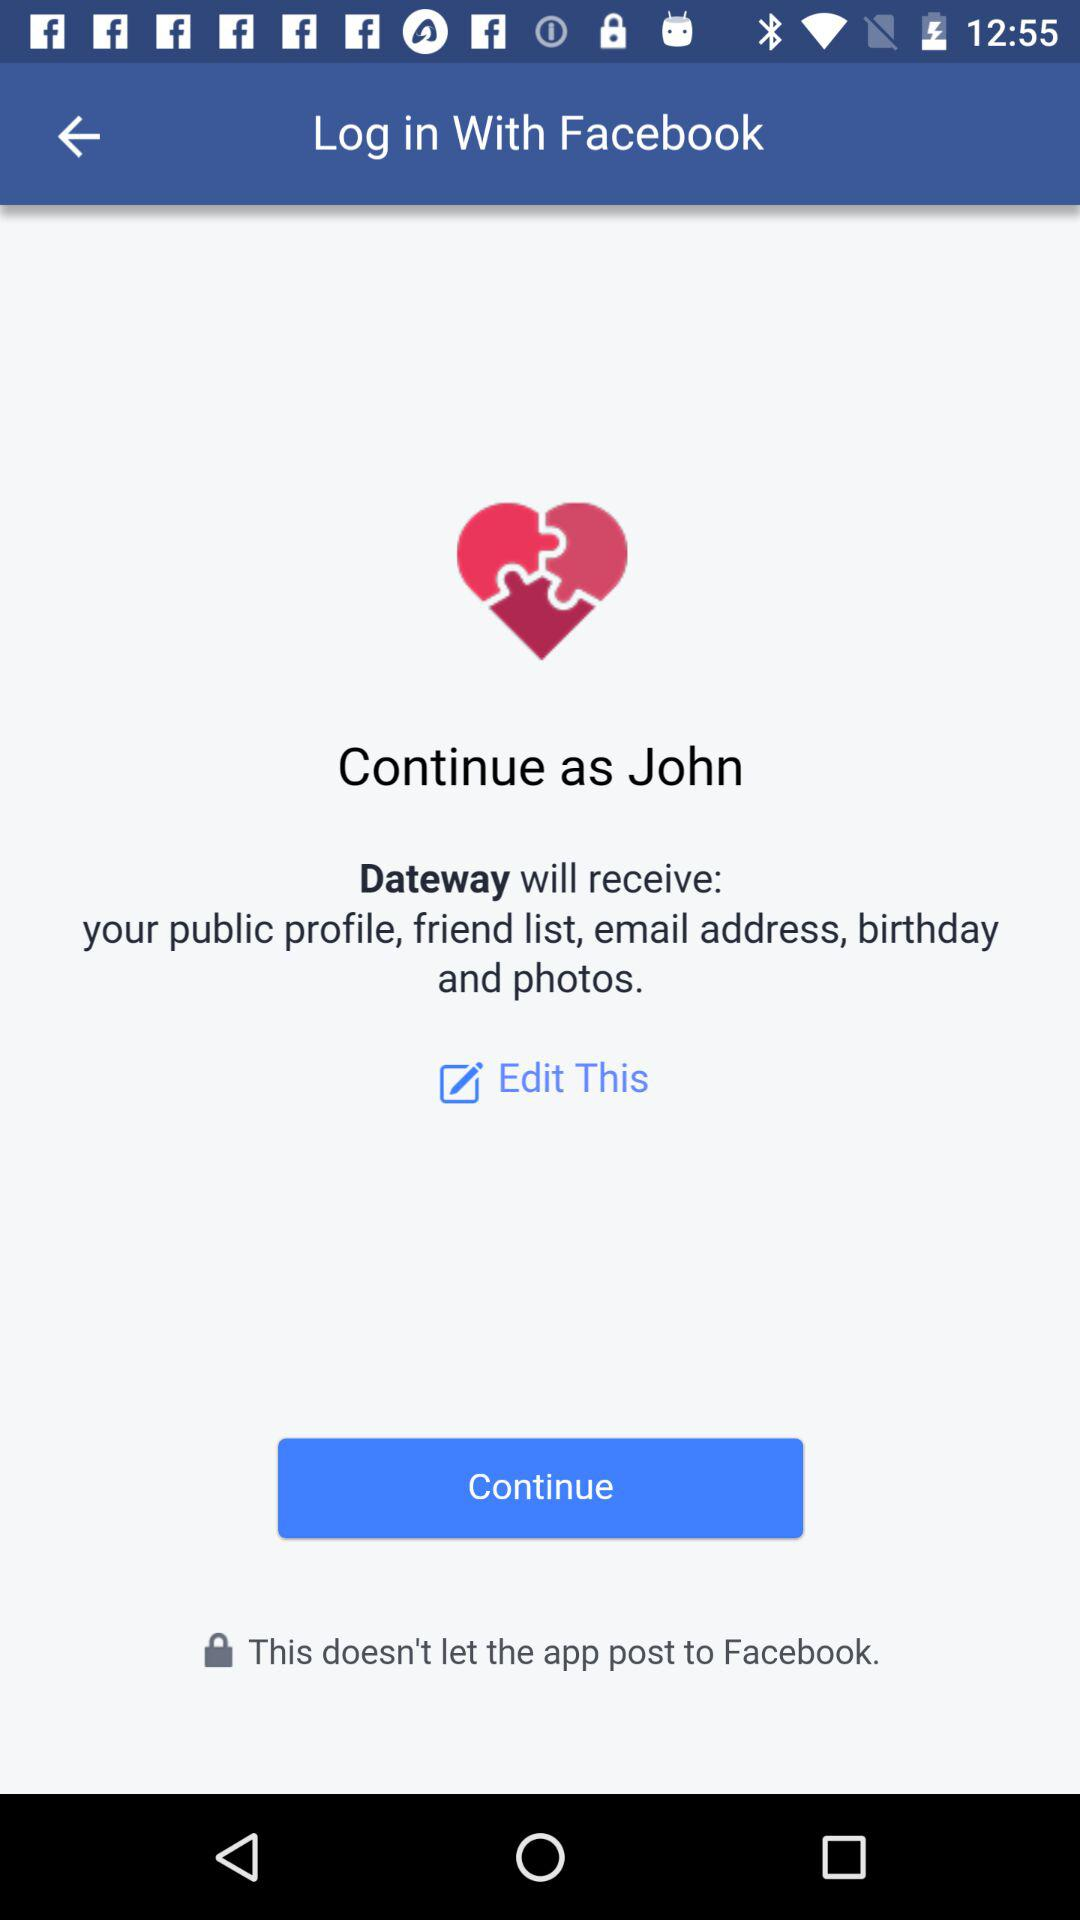What is the user name? The user name is John. 